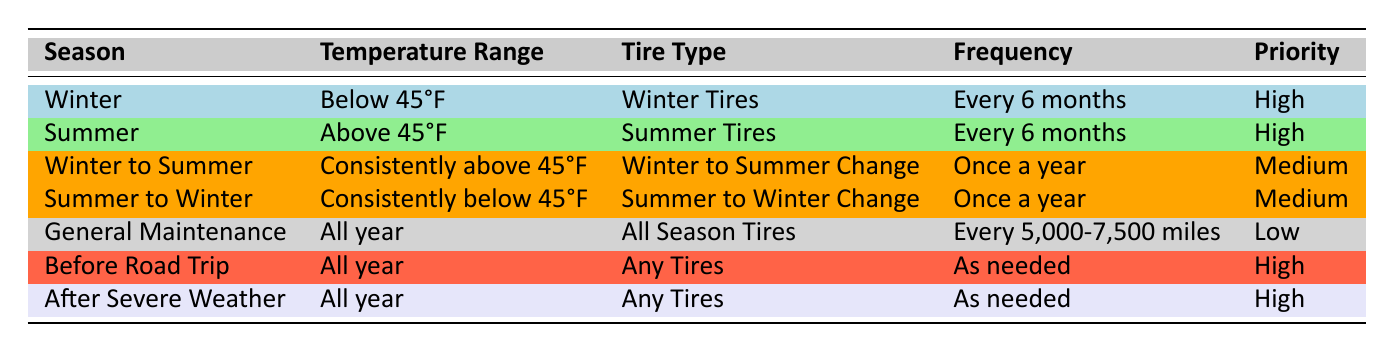What type of tires should be used in winter? According to the table, in the winter season, the recommended tire type is Winter Tires.
Answer: Winter Tires How often should summer tires be changed? The table indicates that summer tires should be changed every 6 months.
Answer: Every 6 months Is the priority level for "Before Road Trip" high or low? The table shows that the priority level for "Before Road Trip" is High.
Answer: High Are all-season tires recommended for general maintenance? Yes, the table lists all-season tires as the appropriate tires for general maintenance.
Answer: Yes What is the frequency for changing tires during the transition from winter to summer? The table states that tires should be changed once a year during the transition from winter to summer.
Answer: Once a year How many seasonal changes have a medium priority level? The table lists two seasonal changes (Winter to Summer Change and Summer to Winter Change) that have a medium priority level.
Answer: 2 If the temperature is consistently below 45°F, which type of tire change is recommended? The table indicates that if the temperature is consistently below 45°F, the recommended tire change is from Summer to Winter.
Answer: Summer to Winter Change What is the frequency for changing tires after severe weather? According to the table, the frequency for changing tires after severe weather is "As needed."
Answer: As needed Which season has the lowest priority level? The table shows that the General Maintenance season has the lowest priority level, categorized as Low.
Answer: General Maintenance 